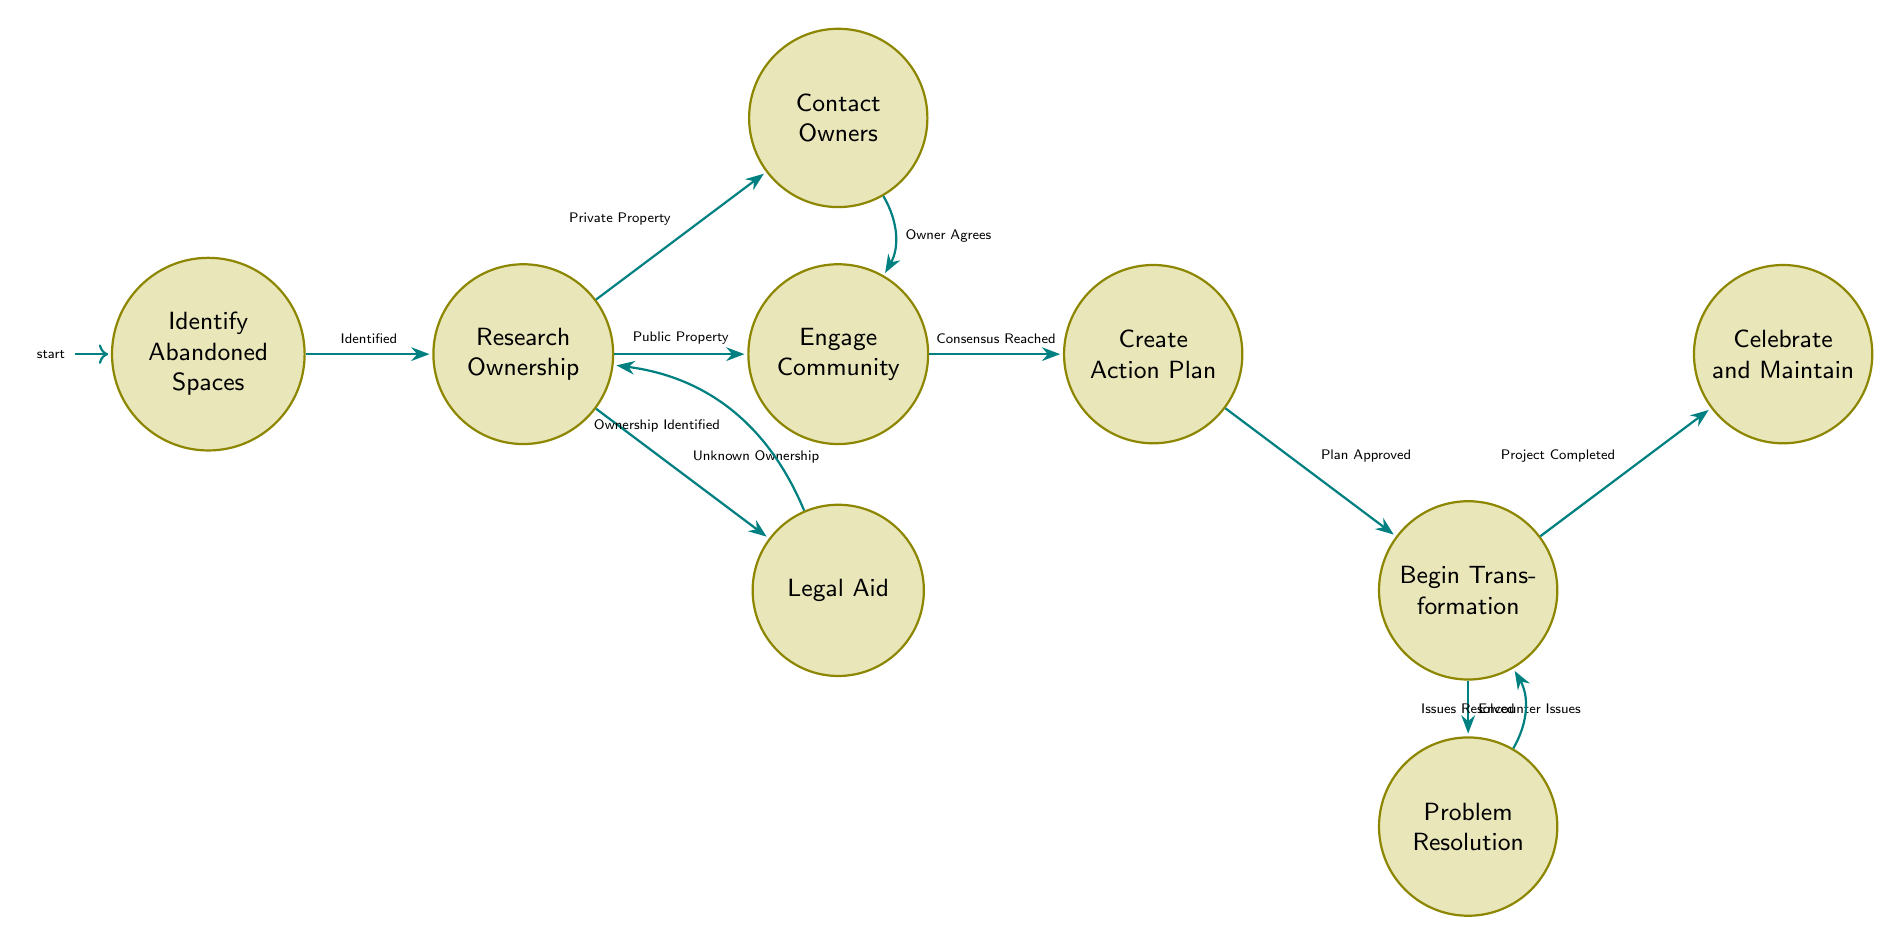What is the starting state of the process? The starting state is identified in the diagram as "Identify Abandoned Spaces." This is represented as the initial node from which all transitions begin.
Answer: Identify Abandoned Spaces How many main states are present in the diagram? To find the number of main states, we can count each distinct state represented in the diagram. There are a total of 10 states listed.
Answer: 10 What action follows "Research Ownership" if it concerns public property? According to the diagram, if public property is identified during the "Research Ownership" state, the next action is "Engage Community." This is shown as a direct transition.
Answer: Engage Community What happens after "Begin Transformation" if project issues arise? If issues arise during the "Begin Transformation" state, the next step is "Problem Resolution," as indicated by an outgoing transition from that state.
Answer: Problem Resolution What do we need to reach after "Engage Community"? Following "Engage Community," if a consensus is reached, the next step will be "Create Action Plan," showing the path forward in the process.
Answer: Create Action Plan What is the consequence of an unresolved issue in "Problem Resolution"? If the issues remain unresolved in "Problem Resolution," the process will conclude as indicated by the transition to "End" state.
Answer: End What is the outcome after "Celebrate and Maintain"? Once "Celebrate and Maintain" is completed and the space is maintained, the process concludes and transitions to the "End" state, marking the successful completion of the steps.
Answer: End What occurs if the action plan is rejected? If the action plan is rejected after "Create Action Plan," the next action will be to "Revise Plan," indicating that modifications are necessary before proceeding.
Answer: Revise Plan What is the relationship between "Contact Owners" and "Engage Community"? The relationship is that "Engage Community" can be reached from "Contact Owners" if the property owner agrees to discuss uses for the space, signifying a positive outcome.
Answer: Owner Agrees 